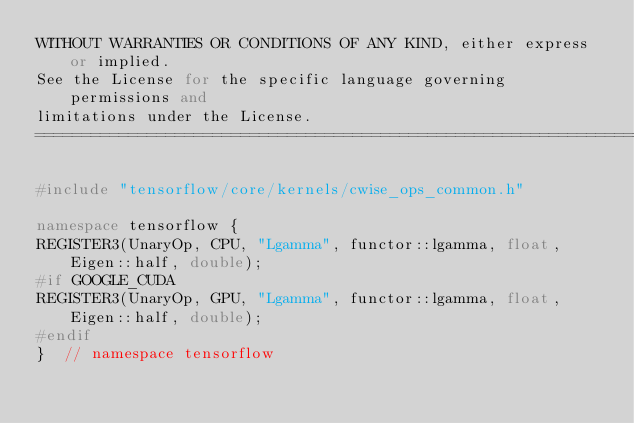<code> <loc_0><loc_0><loc_500><loc_500><_C++_>WITHOUT WARRANTIES OR CONDITIONS OF ANY KIND, either express or implied.
See the License for the specific language governing permissions and
limitations under the License.
==============================================================================*/

#include "tensorflow/core/kernels/cwise_ops_common.h"

namespace tensorflow {
REGISTER3(UnaryOp, CPU, "Lgamma", functor::lgamma, float, Eigen::half, double);
#if GOOGLE_CUDA
REGISTER3(UnaryOp, GPU, "Lgamma", functor::lgamma, float, Eigen::half, double);
#endif
}  // namespace tensorflow
</code> 